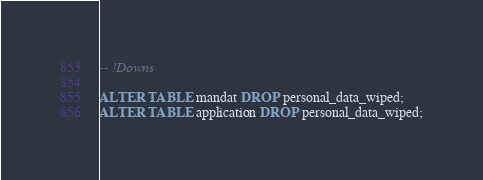Convert code to text. <code><loc_0><loc_0><loc_500><loc_500><_SQL_>
-- !Downs

ALTER TABLE mandat DROP personal_data_wiped;
ALTER TABLE application DROP personal_data_wiped;
</code> 